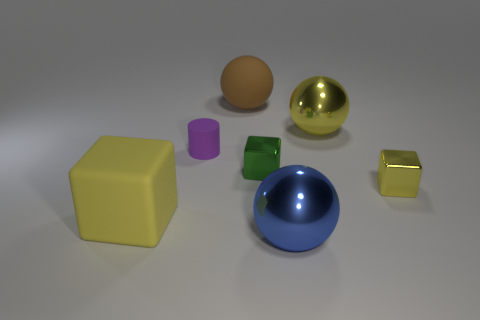Subtract all tiny metal blocks. How many blocks are left? 1 Subtract all yellow balls. How many yellow blocks are left? 2 Add 1 tiny metallic blocks. How many objects exist? 8 Subtract all red balls. Subtract all brown cubes. How many balls are left? 3 Subtract all blocks. How many objects are left? 4 Subtract all yellow metallic things. Subtract all gray objects. How many objects are left? 5 Add 7 blue spheres. How many blue spheres are left? 8 Add 1 large yellow metallic spheres. How many large yellow metallic spheres exist? 2 Subtract 0 cyan spheres. How many objects are left? 7 